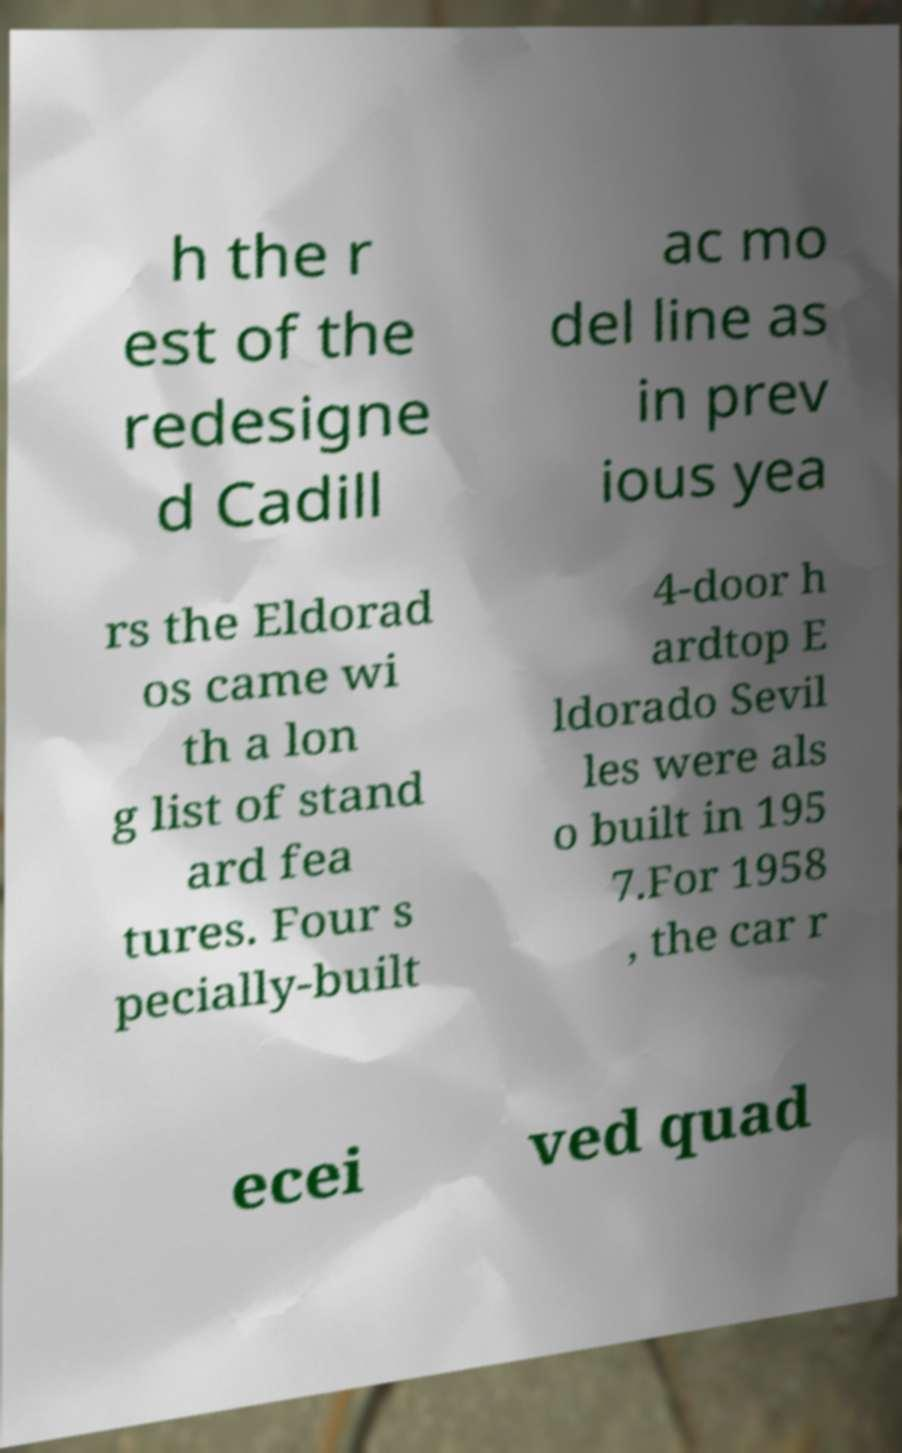Could you extract and type out the text from this image? h the r est of the redesigne d Cadill ac mo del line as in prev ious yea rs the Eldorad os came wi th a lon g list of stand ard fea tures. Four s pecially-built 4-door h ardtop E ldorado Sevil les were als o built in 195 7.For 1958 , the car r ecei ved quad 